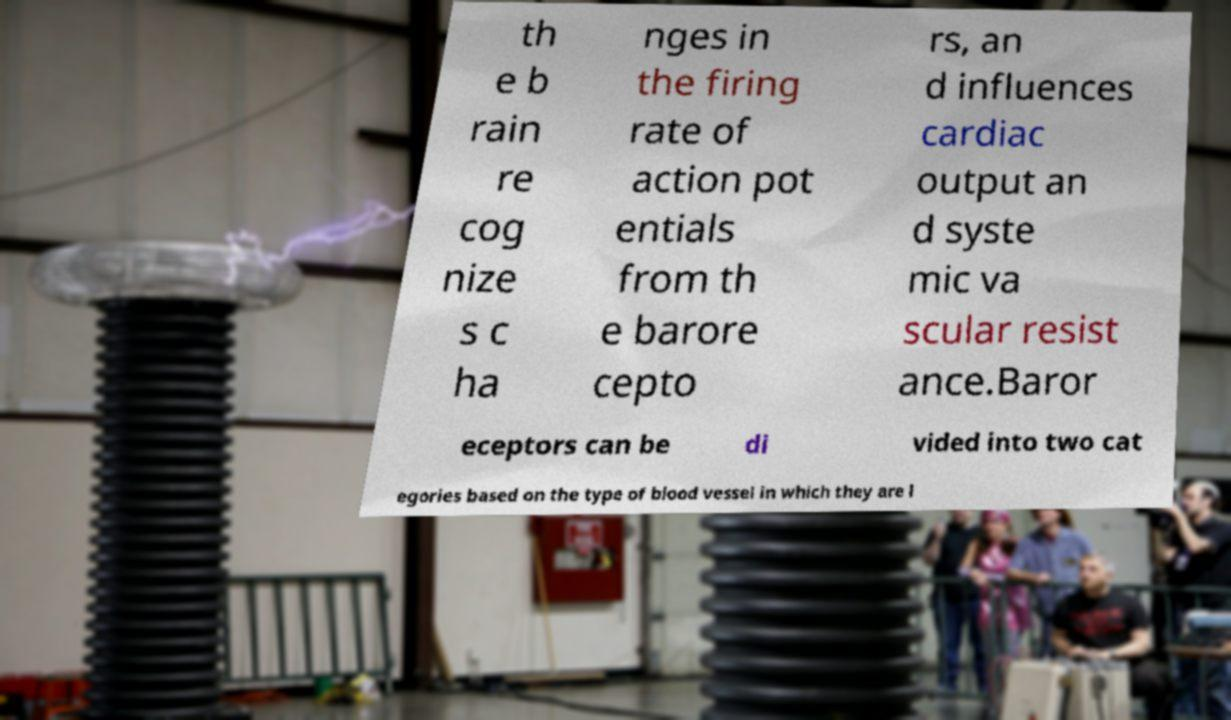Please identify and transcribe the text found in this image. th e b rain re cog nize s c ha nges in the firing rate of action pot entials from th e barore cepto rs, an d influences cardiac output an d syste mic va scular resist ance.Baror eceptors can be di vided into two cat egories based on the type of blood vessel in which they are l 